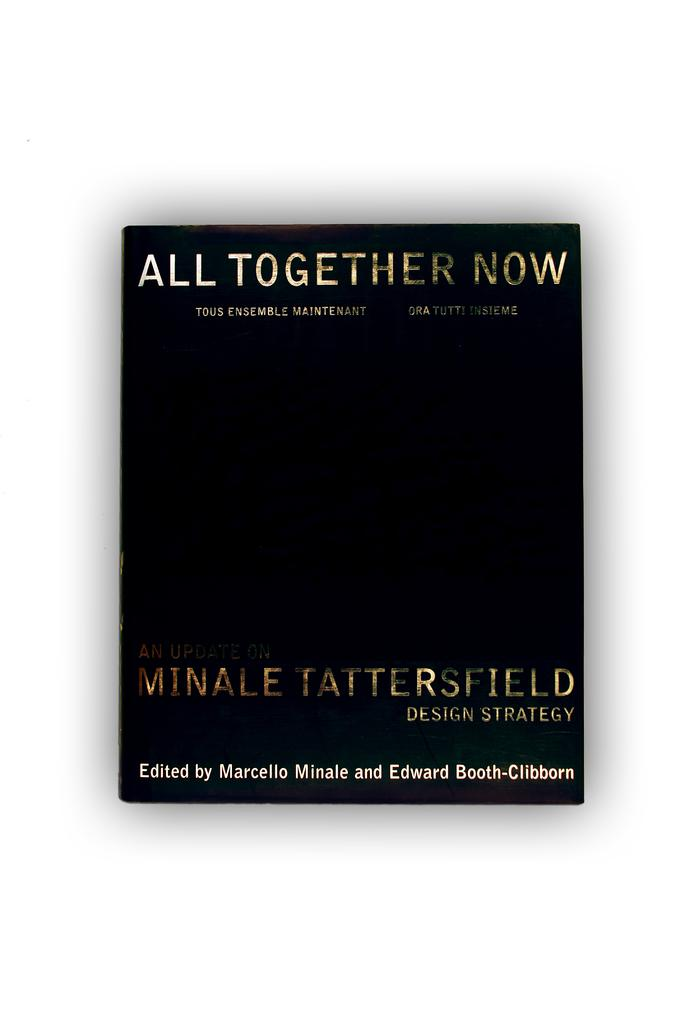<image>
Create a compact narrative representing the image presented. Here we have a black book with a title of "All Together Now' written by Minale Tattersfield Design Strategy 